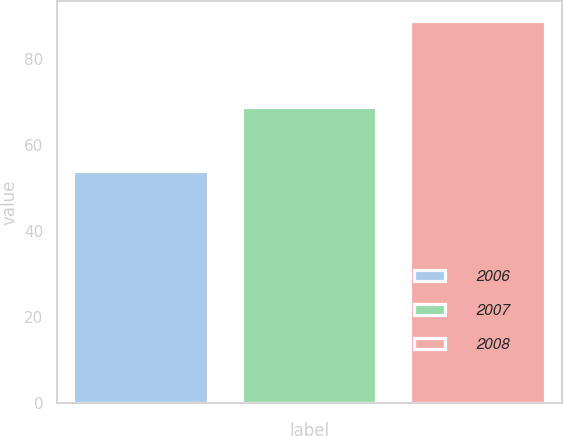<chart> <loc_0><loc_0><loc_500><loc_500><bar_chart><fcel>2006<fcel>2007<fcel>2008<nl><fcel>54<fcel>69<fcel>89<nl></chart> 